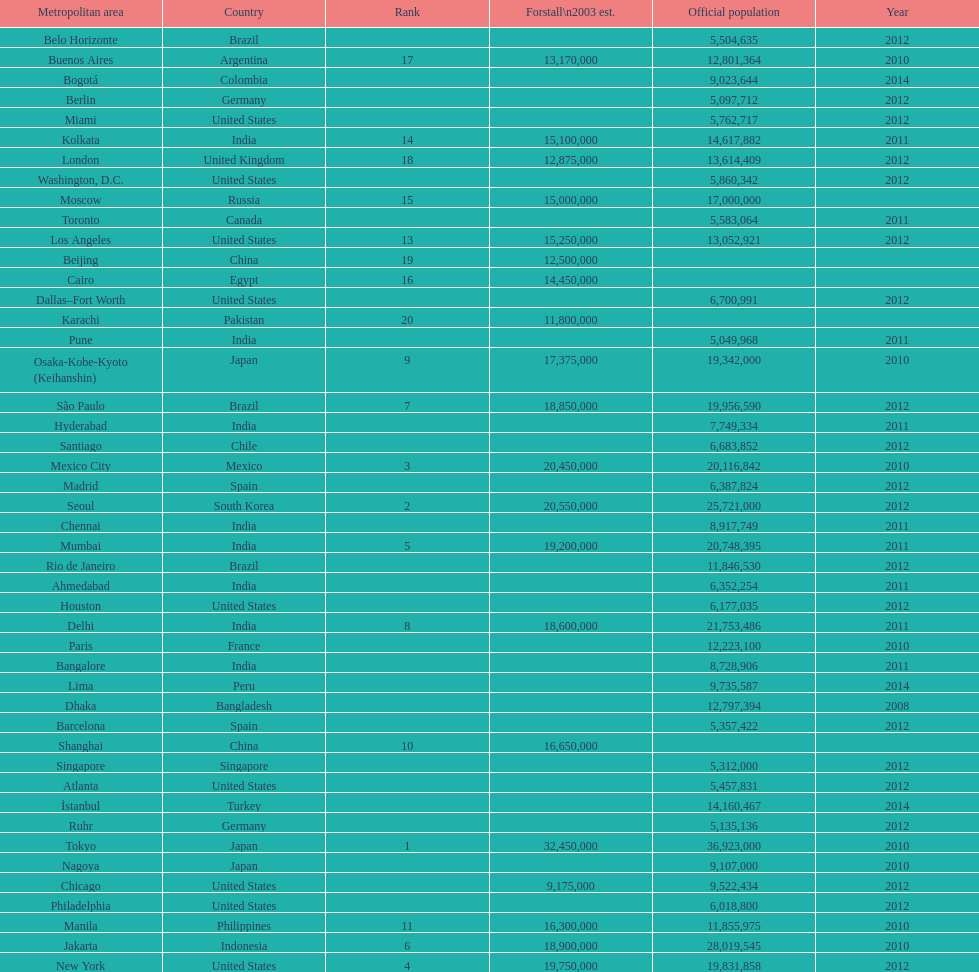Name a city from the same country as bangalore. Ahmedabad. 